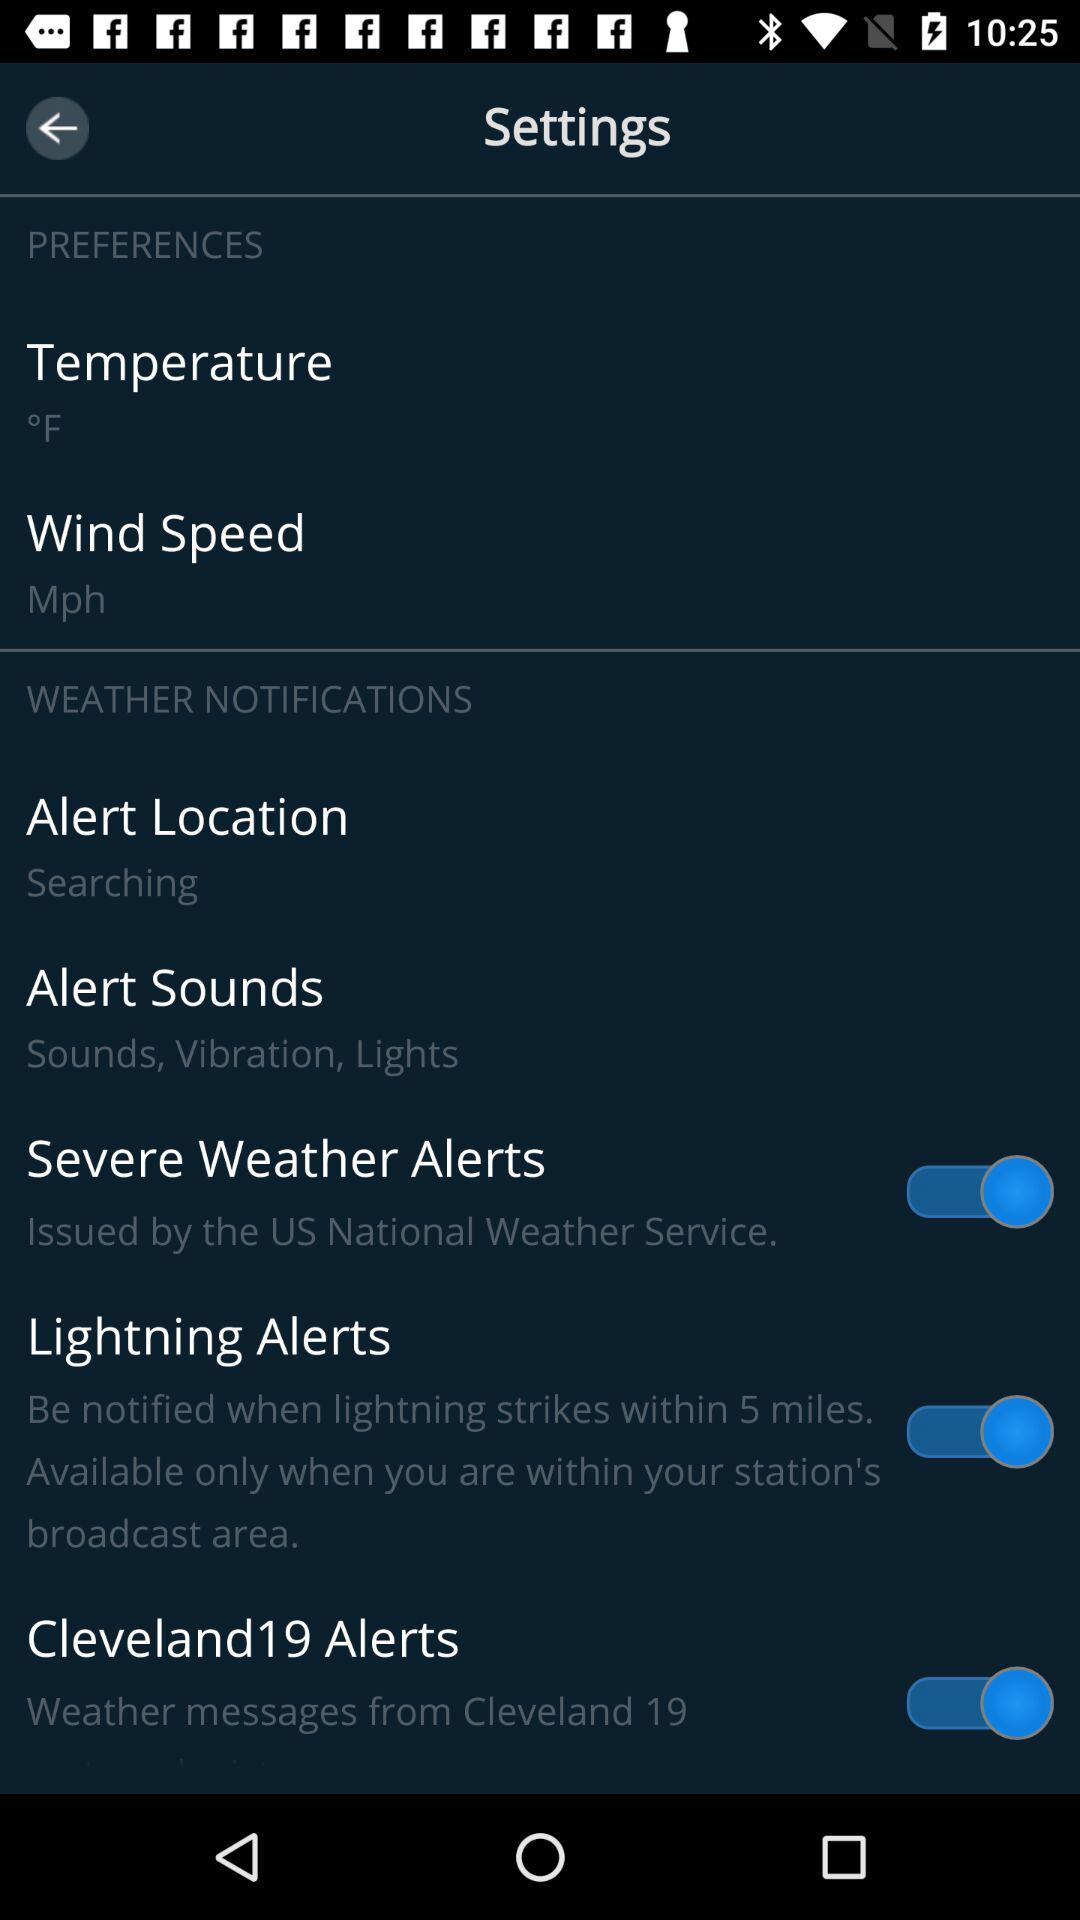What is the setting for "Alert Sounds"? The setting for "Alert Sounds" is "Sounds, Vibration, Lights". 